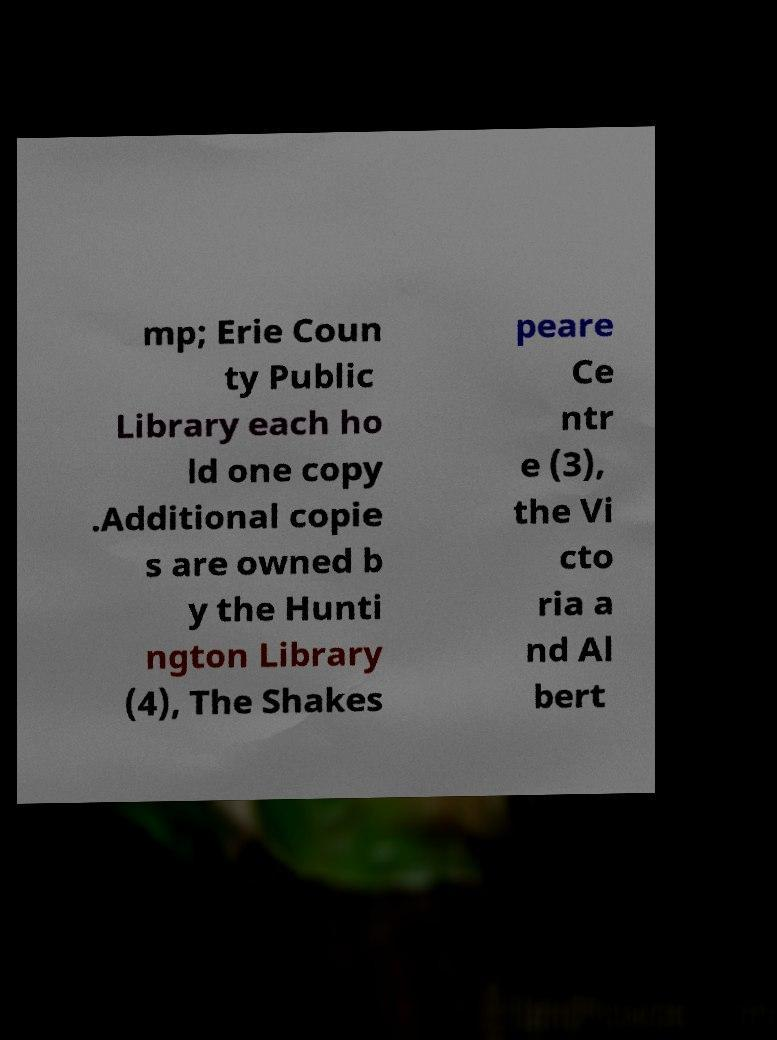I need the written content from this picture converted into text. Can you do that? mp; Erie Coun ty Public Library each ho ld one copy .Additional copie s are owned b y the Hunti ngton Library (4), The Shakes peare Ce ntr e (3), the Vi cto ria a nd Al bert 